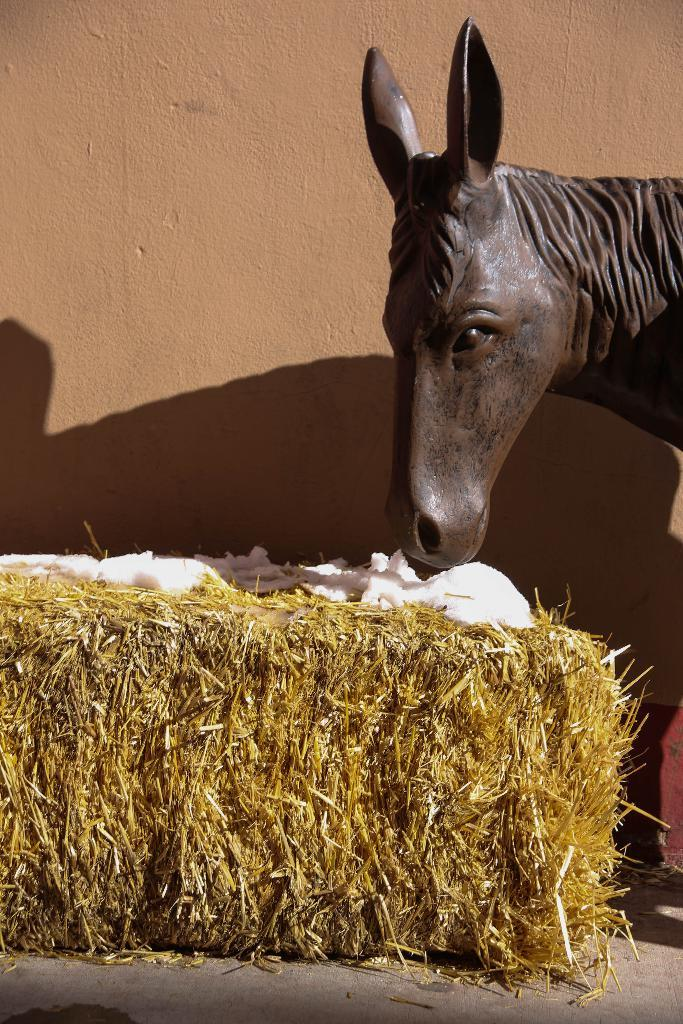What is the main subject of the image? There is a statue of a horse in the image. What type of natural environment is visible in the image? There is grass visible in the image. Are there any other objects or structures in the image? Yes, there are other objects in the image. What can be seen in the background of the image? There is a wall in the background of the image. What is the surface on which the statue and other objects are placed? There is a floor at the bottom of the image. What type of geese are present at the meeting in the image? There are no geese or meetings present in the image; it features a statue of a horse, grass, and other objects. What type of ray is visible near the statue in the image? There is no ray visible in the image; it only features a statue of a horse, grass, and other objects. 